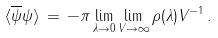Convert formula to latex. <formula><loc_0><loc_0><loc_500><loc_500>\langle \overline { \psi } \psi \rangle \, = \, - \pi \lim _ { \lambda \to 0 } \lim _ { V \to \infty } \rho ( \lambda ) V ^ { - 1 } \, .</formula> 